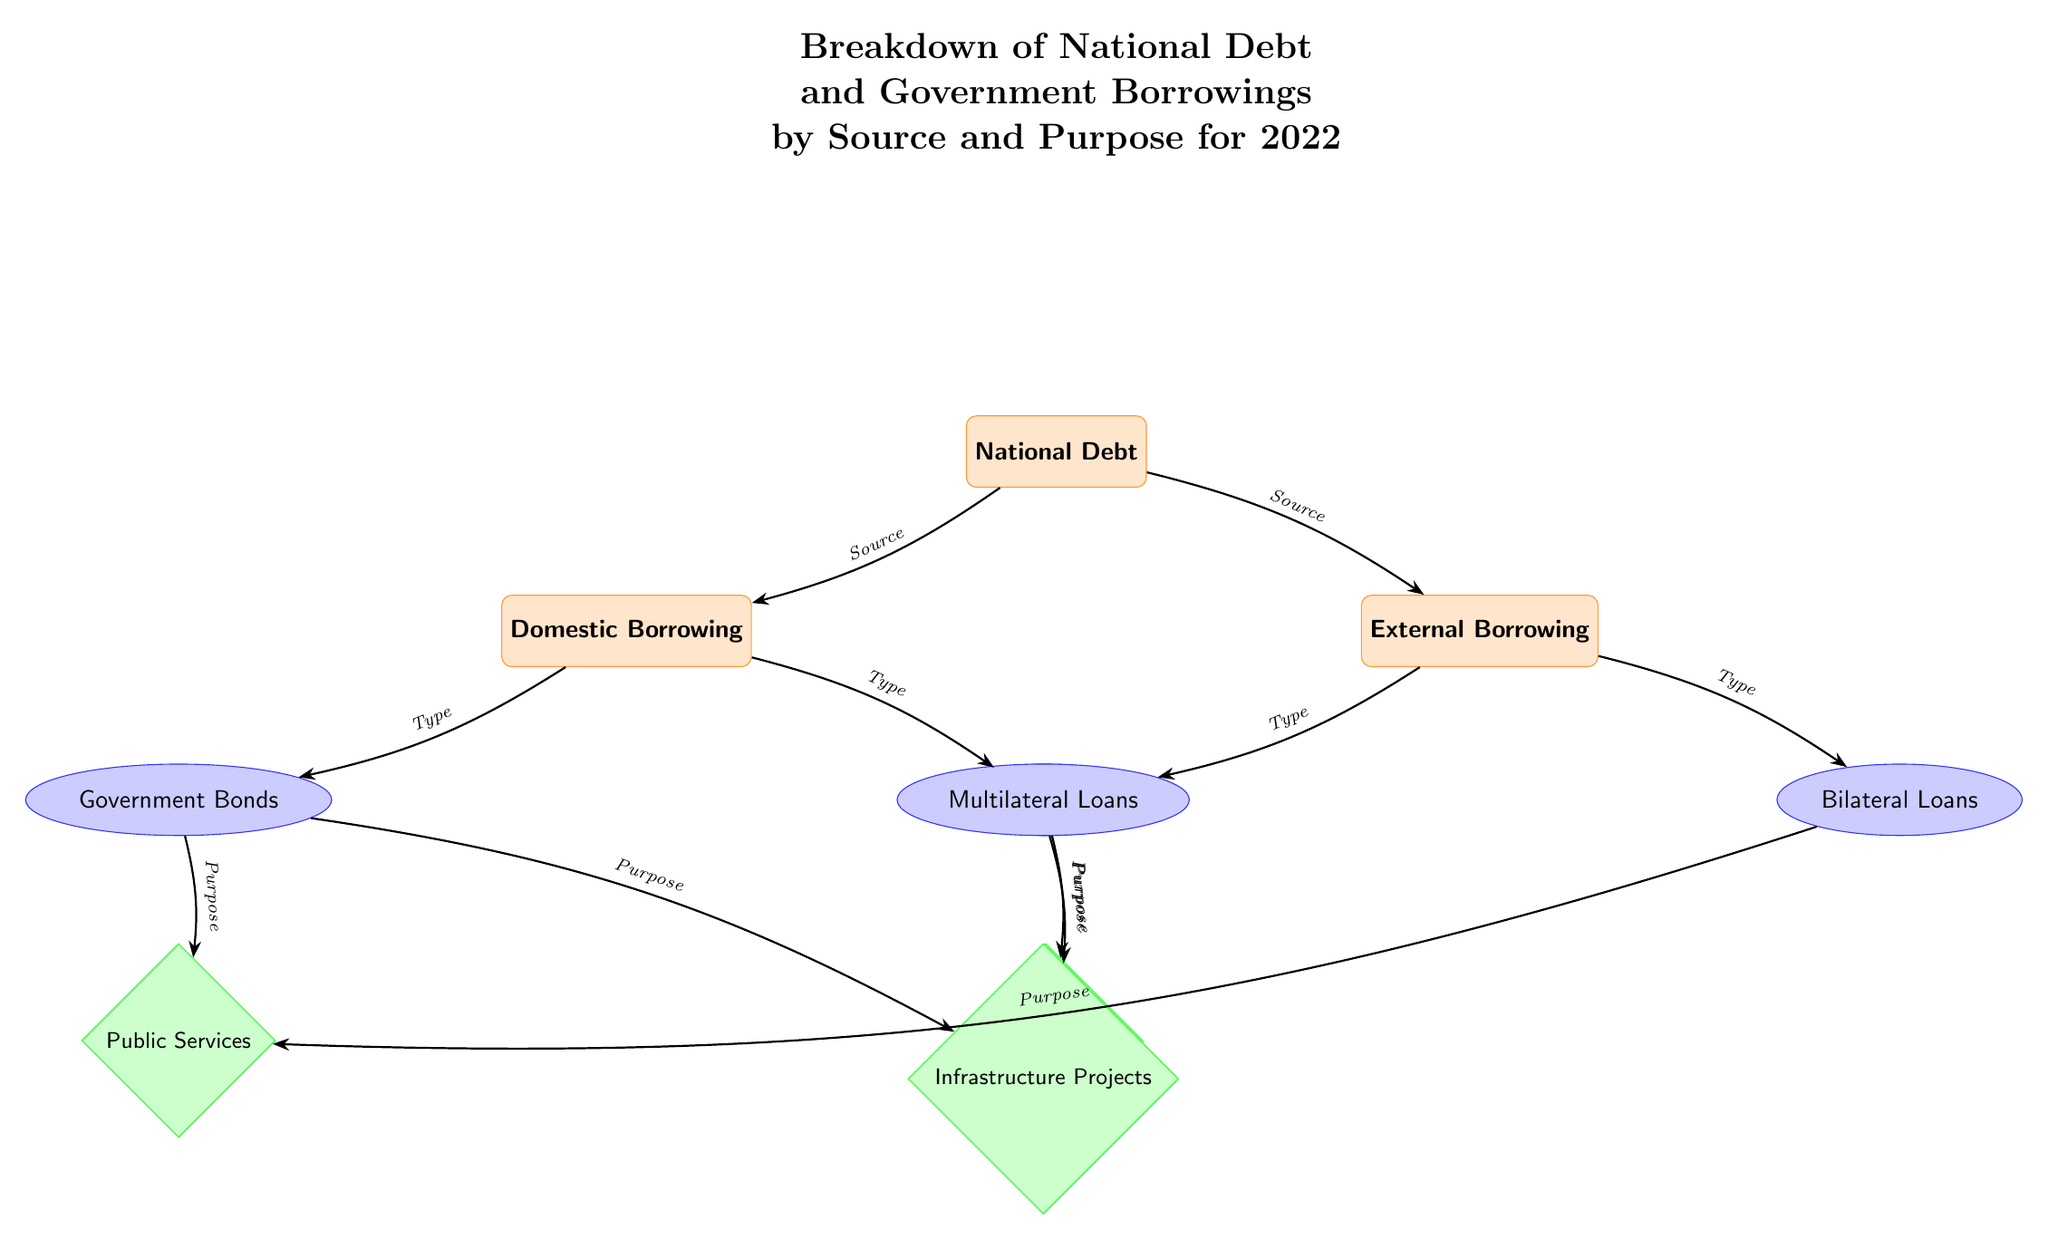What are the two main sources of National Debt? The diagram shows that the two main sources of National Debt are Domestic Borrowing and External Borrowing, as indicated by the two nodes directly beneath the National Debt category.
Answer: Domestic Borrowing, External Borrowing What type of borrowing is categorized under Domestic Borrowing? The diagram indicates that Domestic Borrowing is broken down into two types: Government Bonds and Treasury Bills, which are represented as subcategories under Domestic Borrowing.
Answer: Government Bonds, Treasury Bills Which purpose is linked to Treasury Bills? According to the diagram, Treasury Bills are linked to the purpose of Debt Servicing, as shown by the arrow connecting Treasury Bills to the corresponding purpose node.
Answer: Debt Servicing How many types of External Borrowing are represented in the diagram? The diagram features two types of External Borrowing, which are Multilateral Loans and Bilateral Loans, as indicated by the two subcategory nodes under External Borrowing.
Answer: 2 What is the relationship between Government Bonds and Infrastructure Projects? The diagram shows that Government Bonds are linked to two purposes, one of which is Infrastructure Projects, indicated by an arrow pointing from the Government Bonds node to the Infrastructure Projects purpose node.
Answer: Link Which source does Multilateral Loans fall under? The diagram categorizes Multilateral Loans under External Borrowing, as indicated by the position of the Multilateral Loans node directly connected to the External Borrowing category.
Answer: External Borrowing What purpose is associated with both Government Bonds and Bilateral Loans? According to the diagram, both Government Bonds and Bilateral Loans are linked to the purpose of Public Services, as shown by individual arrows from each type to the Public Services purpose node.
Answer: Public Services What is the total number of purpose nodes in the diagram? The diagram includes three purpose nodes: Public Services, Debt Servicing, and Infrastructure Projects, making the total number of purpose nodes three.
Answer: 3 Which type of borrowing is the primary source for funding Infrastructure Projects? The diagram shows that Infrastructure Projects are funded by both Government Bonds and Multilateral Loans, connecting each respective type to the Infrastructure Projects purpose node.
Answer: Government Bonds, Multilateral Loans 